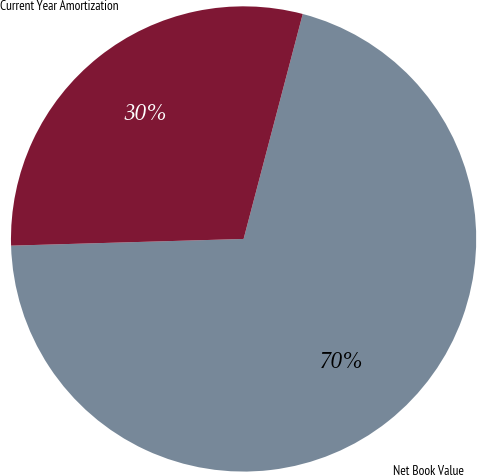<chart> <loc_0><loc_0><loc_500><loc_500><pie_chart><fcel>Net Book Value<fcel>Current Year Amortization<nl><fcel>70.45%<fcel>29.55%<nl></chart> 